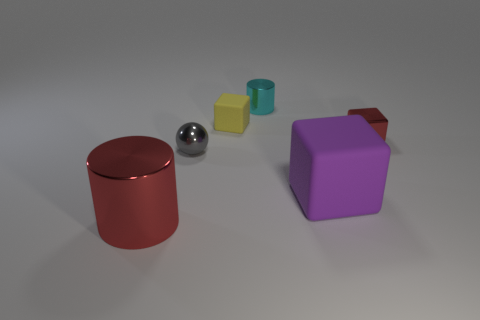There is a red thing that is left of the purple cube; is its size the same as the small sphere?
Give a very brief answer. No. What material is the other yellow object that is the same shape as the large rubber object?
Your answer should be very brief. Rubber. Does the tiny cyan thing have the same shape as the big red thing?
Provide a short and direct response. Yes. There is a metallic object to the right of the small cyan object; how many yellow cubes are in front of it?
Your response must be concise. 0. There is another object that is the same material as the big purple thing; what is its shape?
Offer a very short reply. Cube. What number of yellow things are tiny cubes or large metal cylinders?
Provide a succinct answer. 1. There is a large purple rubber cube that is right of the large thing to the left of the large purple matte object; are there any gray things that are in front of it?
Provide a short and direct response. No. Are there fewer red matte cylinders than cyan shiny objects?
Offer a very short reply. Yes. There is a rubber object that is in front of the gray thing; is its shape the same as the gray object?
Give a very brief answer. No. Are there any yellow objects?
Your answer should be compact. Yes. 